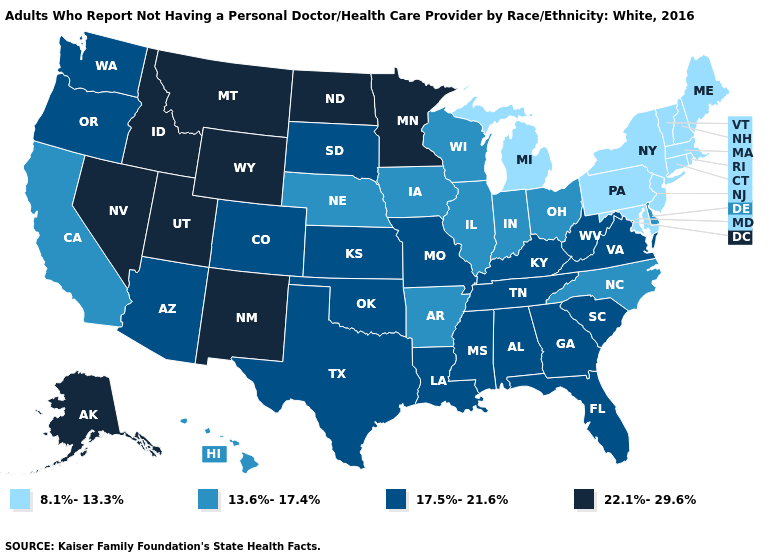Which states have the lowest value in the USA?
Keep it brief. Connecticut, Maine, Maryland, Massachusetts, Michigan, New Hampshire, New Jersey, New York, Pennsylvania, Rhode Island, Vermont. Name the states that have a value in the range 17.5%-21.6%?
Write a very short answer. Alabama, Arizona, Colorado, Florida, Georgia, Kansas, Kentucky, Louisiana, Mississippi, Missouri, Oklahoma, Oregon, South Carolina, South Dakota, Tennessee, Texas, Virginia, Washington, West Virginia. Name the states that have a value in the range 17.5%-21.6%?
Short answer required. Alabama, Arizona, Colorado, Florida, Georgia, Kansas, Kentucky, Louisiana, Mississippi, Missouri, Oklahoma, Oregon, South Carolina, South Dakota, Tennessee, Texas, Virginia, Washington, West Virginia. Which states hav the highest value in the Northeast?
Keep it brief. Connecticut, Maine, Massachusetts, New Hampshire, New Jersey, New York, Pennsylvania, Rhode Island, Vermont. Does Maryland have the lowest value in the South?
Short answer required. Yes. Which states have the lowest value in the MidWest?
Be succinct. Michigan. Does Massachusetts have the lowest value in the USA?
Give a very brief answer. Yes. What is the highest value in the Northeast ?
Be succinct. 8.1%-13.3%. Does Georgia have the highest value in the USA?
Concise answer only. No. Among the states that border Oklahoma , which have the lowest value?
Answer briefly. Arkansas. What is the value of South Carolina?
Write a very short answer. 17.5%-21.6%. What is the value of Florida?
Give a very brief answer. 17.5%-21.6%. Name the states that have a value in the range 13.6%-17.4%?
Answer briefly. Arkansas, California, Delaware, Hawaii, Illinois, Indiana, Iowa, Nebraska, North Carolina, Ohio, Wisconsin. Does New Hampshire have the lowest value in the USA?
Short answer required. Yes. Does Hawaii have the highest value in the West?
Give a very brief answer. No. 